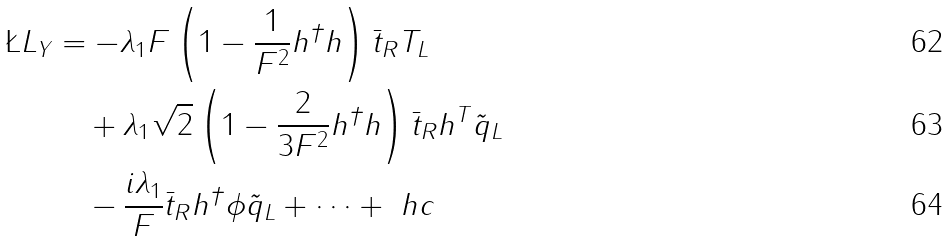<formula> <loc_0><loc_0><loc_500><loc_500>\L L _ { Y } & = - \lambda _ { 1 } F \left ( 1 - \frac { 1 } { F ^ { 2 } } h ^ { \dagger } h \right ) \bar { t } _ { R } T _ { L } \\ & \quad + \lambda _ { 1 } \sqrt { 2 } \left ( 1 - \frac { 2 } { 3 F ^ { 2 } } h ^ { \dagger } h \right ) \bar { t } _ { R } h ^ { T } \tilde { q } _ { L } \\ & \quad - \frac { i \lambda _ { 1 } } { F } \bar { t } _ { R } h ^ { \dagger } \phi \tilde { q } _ { L } + \dots + \ h c</formula> 